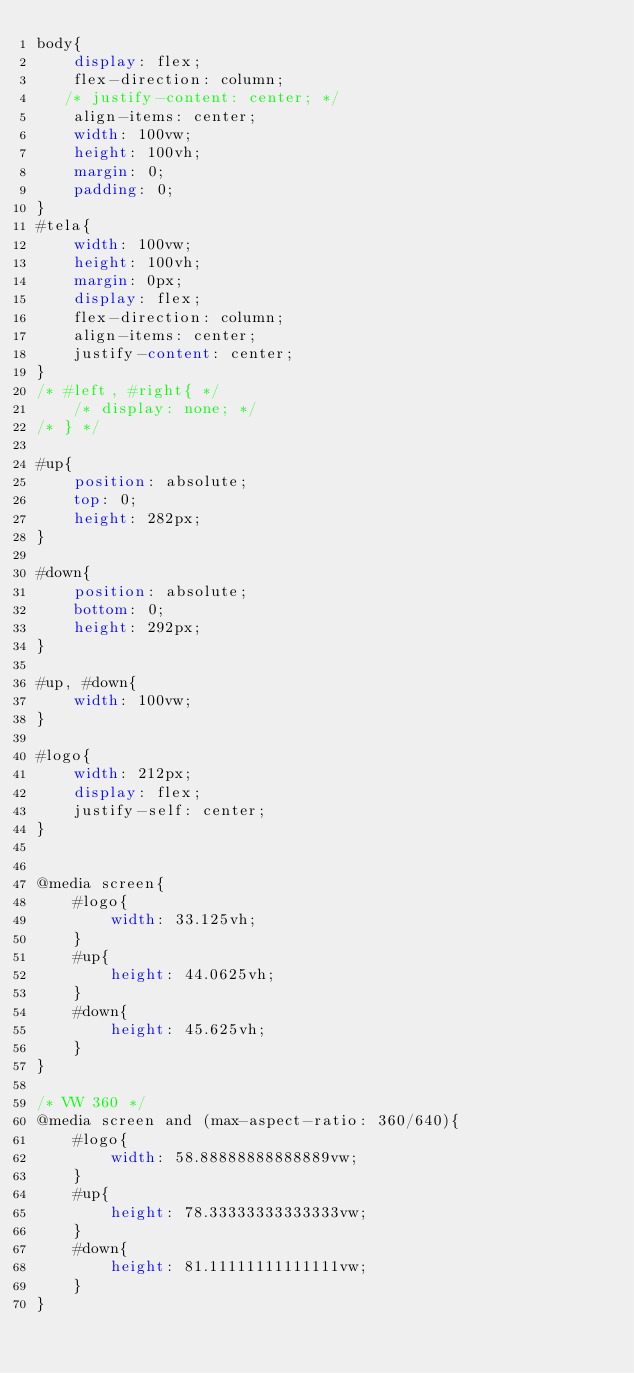<code> <loc_0><loc_0><loc_500><loc_500><_CSS_>body{
    display: flex;
    flex-direction: column;
   /* justify-content: center; */
    align-items: center;
    width: 100vw;
    height: 100vh;
    margin: 0;
    padding: 0;
}
#tela{
    width: 100vw;
    height: 100vh;
    margin: 0px;
    display: flex;
    flex-direction: column;
    align-items: center;
    justify-content: center;
}
/* #left, #right{ */
    /* display: none; */
/* } */

#up{
    position: absolute;
    top: 0;
    height: 282px;
}

#down{
    position: absolute;
    bottom: 0;
    height: 292px;
}

#up, #down{
    width: 100vw;
}

#logo{    
    width: 212px;
    display: flex;
    justify-self: center;   
}


@media screen{
    #logo{
        width: 33.125vh;
    }
    #up{
        height: 44.0625vh;
    }
    #down{
        height: 45.625vh;
    }
}

/* VW 360 */
@media screen and (max-aspect-ratio: 360/640){
    #logo{
        width: 58.88888888888889vw;
    }
    #up{
        height: 78.33333333333333vw;
    }
    #down{
        height: 81.11111111111111vw;
    }
}</code> 